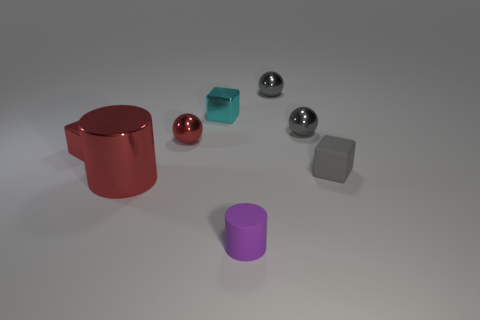What material is the sphere that is the same color as the large thing?
Keep it short and to the point. Metal. There is another shiny object that is the same shape as the small cyan metal thing; what size is it?
Give a very brief answer. Small. Does the matte thing that is on the right side of the tiny purple object have the same color as the large metallic cylinder?
Keep it short and to the point. No. Is the number of cyan objects less than the number of red shiny objects?
Your answer should be very brief. Yes. What number of other things are the same color as the rubber block?
Keep it short and to the point. 2. Is the material of the block on the right side of the tiny cyan object the same as the small red ball?
Keep it short and to the point. No. There is a small ball left of the purple rubber cylinder; what is its material?
Make the answer very short. Metal. What size is the cube in front of the cube that is to the left of the large object?
Ensure brevity in your answer.  Small. Are there any large cyan cylinders made of the same material as the red cylinder?
Your response must be concise. No. What shape is the rubber thing behind the rubber object left of the cube that is on the right side of the matte cylinder?
Ensure brevity in your answer.  Cube. 